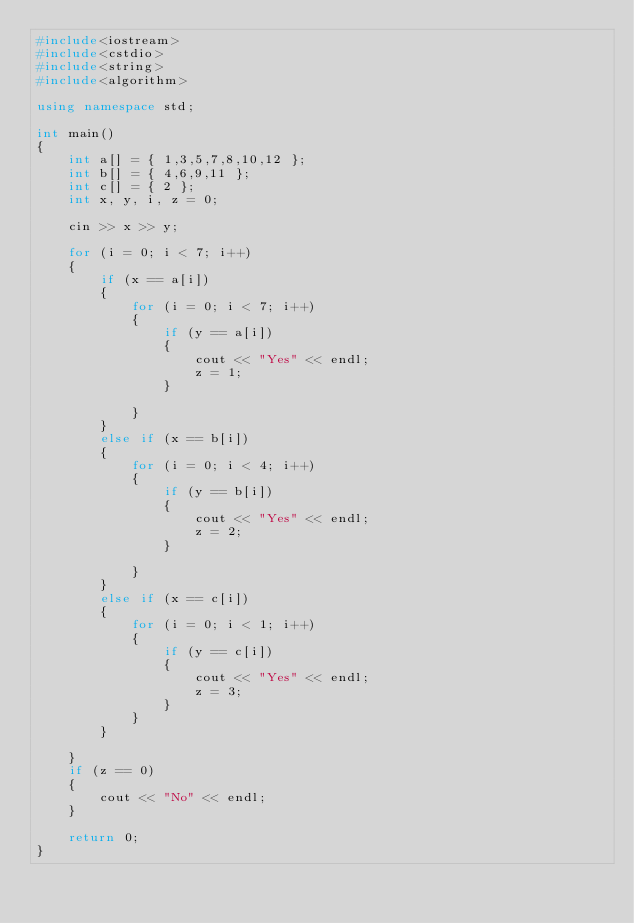<code> <loc_0><loc_0><loc_500><loc_500><_C++_>#include<iostream>
#include<cstdio>
#include<string>
#include<algorithm>

using namespace std;

int main()
{
	int a[] = { 1,3,5,7,8,10,12 };
	int b[] = { 4,6,9,11 };
	int c[] = { 2 };
	int x, y, i, z = 0;

	cin >> x >> y;

	for (i = 0; i < 7; i++)
	{
		if (x == a[i])
		{
			for (i = 0; i < 7; i++)
			{
				if (y == a[i])
				{
					cout << "Yes" << endl;
					z = 1;
				}
				
			}
		}
		else if (x == b[i])
		{
			for (i = 0; i < 4; i++)
			{
				if (y == b[i])
				{
					cout << "Yes" << endl;
					z = 2;
				}

			}
		}
		else if (x == c[i])
		{
			for (i = 0; i < 1; i++)
			{
				if (y == c[i])
				{
					cout << "Yes" << endl;
					z = 3;
				}
			}
		}
		
	}
	if (z == 0)
	{
		cout << "No" << endl;
	}

	return 0;
}</code> 